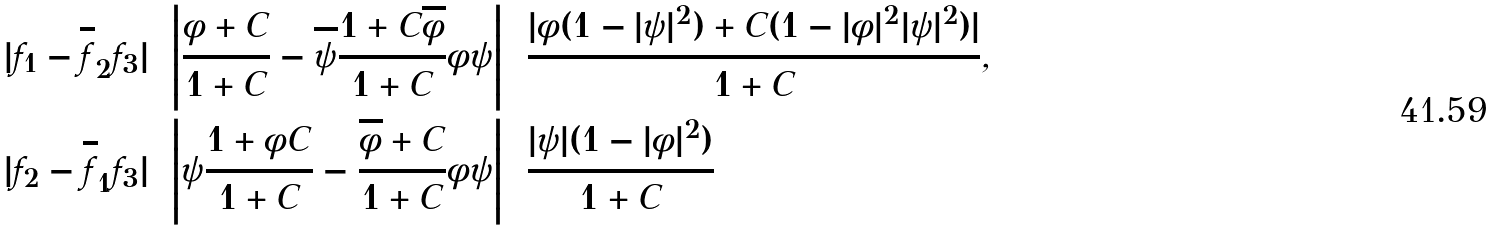<formula> <loc_0><loc_0><loc_500><loc_500>| f _ { 1 } - \overline { f } _ { 2 } f _ { 3 } | & = \left | \frac { \phi + C } { 1 + C } - \overline { \psi } \frac { 1 + C \overline { \phi } } { 1 + C } \phi \psi \right | = \frac { | \phi ( 1 - | \psi | ^ { 2 } ) + C ( 1 - | \phi | ^ { 2 } | \psi | ^ { 2 } ) | } { 1 + C } , \\ | f _ { 2 } - \overline { f } _ { 1 } f _ { 3 } | & = \left | \psi \frac { 1 + \phi C } { 1 + C } - \frac { \overline { \phi } + C } { 1 + C } \phi \psi \right | = \frac { | \psi | ( 1 - | \phi | ^ { 2 } ) } { 1 + C }</formula> 